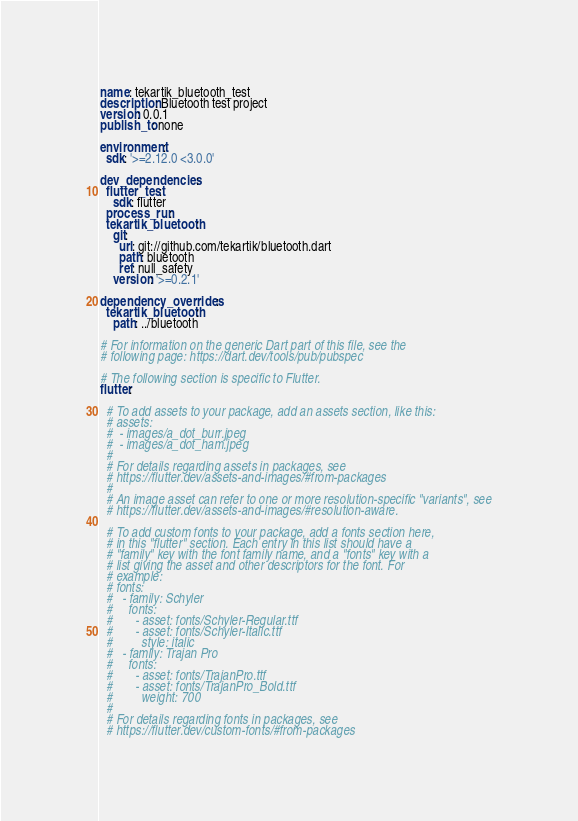<code> <loc_0><loc_0><loc_500><loc_500><_YAML_>name: tekartik_bluetooth_test
description: Bluetooth test project
version: 0.0.1
publish_to: none

environment:
  sdk: '>=2.12.0 <3.0.0'

dev_dependencies:
  flutter_test:
    sdk: flutter
  process_run:
  tekartik_bluetooth:
    git:
      url: git://github.com/tekartik/bluetooth.dart
      path: bluetooth
      ref: null_safety
    version: '>=0.2.1'

dependency_overrides:
  tekartik_bluetooth:
    path: ../bluetooth

# For information on the generic Dart part of this file, see the
# following page: https://dart.dev/tools/pub/pubspec

# The following section is specific to Flutter.
flutter:

  # To add assets to your package, add an assets section, like this:
  # assets:
  #  - images/a_dot_burr.jpeg
  #  - images/a_dot_ham.jpeg
  #
  # For details regarding assets in packages, see
  # https://flutter.dev/assets-and-images/#from-packages
  #
  # An image asset can refer to one or more resolution-specific "variants", see
  # https://flutter.dev/assets-and-images/#resolution-aware.

  # To add custom fonts to your package, add a fonts section here,
  # in this "flutter" section. Each entry in this list should have a
  # "family" key with the font family name, and a "fonts" key with a
  # list giving the asset and other descriptors for the font. For
  # example:
  # fonts:
  #   - family: Schyler
  #     fonts:
  #       - asset: fonts/Schyler-Regular.ttf
  #       - asset: fonts/Schyler-Italic.ttf
  #         style: italic
  #   - family: Trajan Pro
  #     fonts:
  #       - asset: fonts/TrajanPro.ttf
  #       - asset: fonts/TrajanPro_Bold.ttf
  #         weight: 700
  #
  # For details regarding fonts in packages, see
  # https://flutter.dev/custom-fonts/#from-packages</code> 